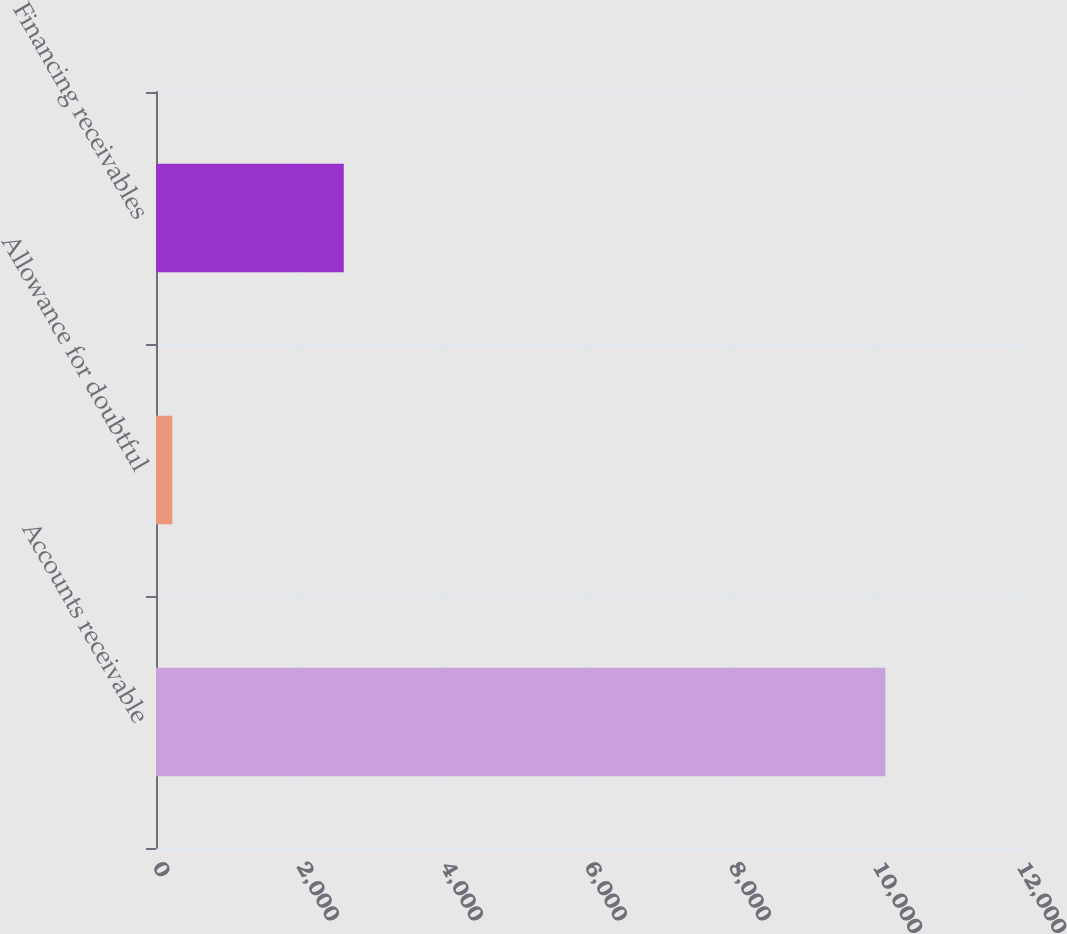<chart> <loc_0><loc_0><loc_500><loc_500><bar_chart><fcel>Accounts receivable<fcel>Allowance for doubtful<fcel>Financing receivables<nl><fcel>10130<fcel>227<fcel>2608<nl></chart> 